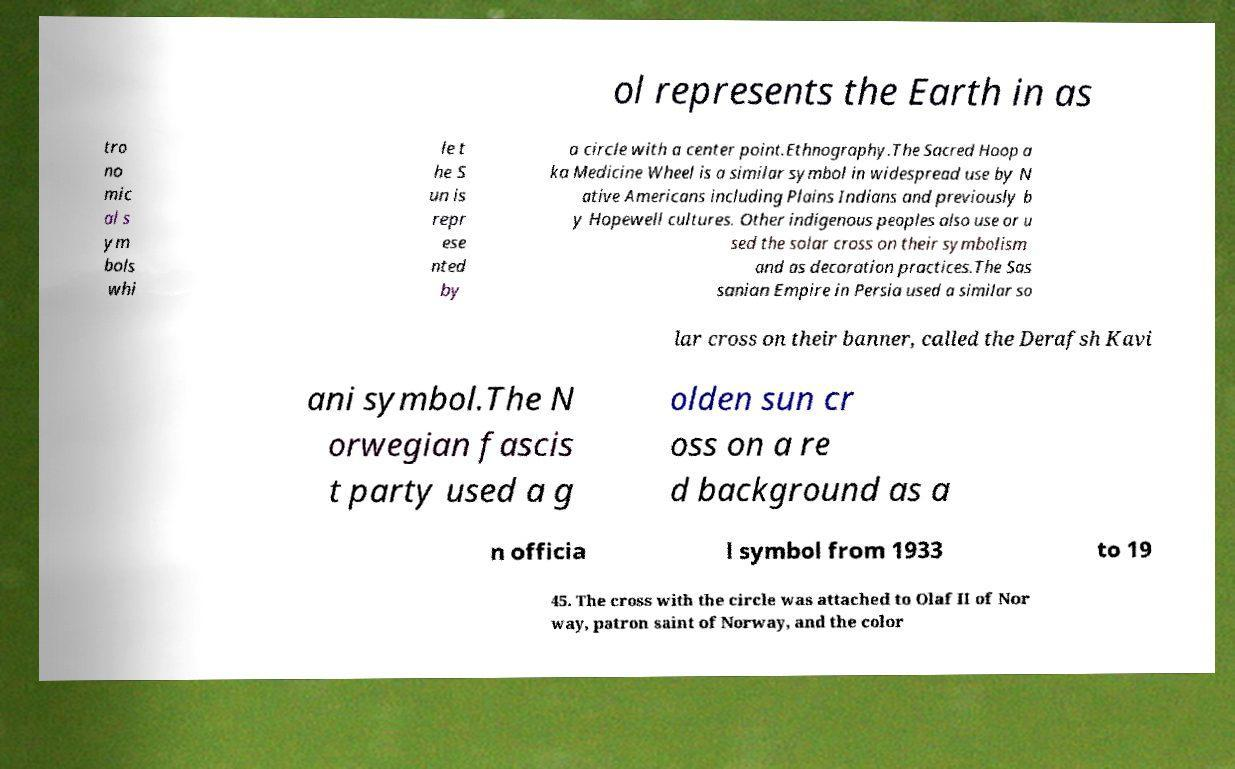I need the written content from this picture converted into text. Can you do that? ol represents the Earth in as tro no mic al s ym bols whi le t he S un is repr ese nted by a circle with a center point.Ethnography.The Sacred Hoop a ka Medicine Wheel is a similar symbol in widespread use by N ative Americans including Plains Indians and previously b y Hopewell cultures. Other indigenous peoples also use or u sed the solar cross on their symbolism and as decoration practices.The Sas sanian Empire in Persia used a similar so lar cross on their banner, called the Derafsh Kavi ani symbol.The N orwegian fascis t party used a g olden sun cr oss on a re d background as a n officia l symbol from 1933 to 19 45. The cross with the circle was attached to Olaf II of Nor way, patron saint of Norway, and the color 